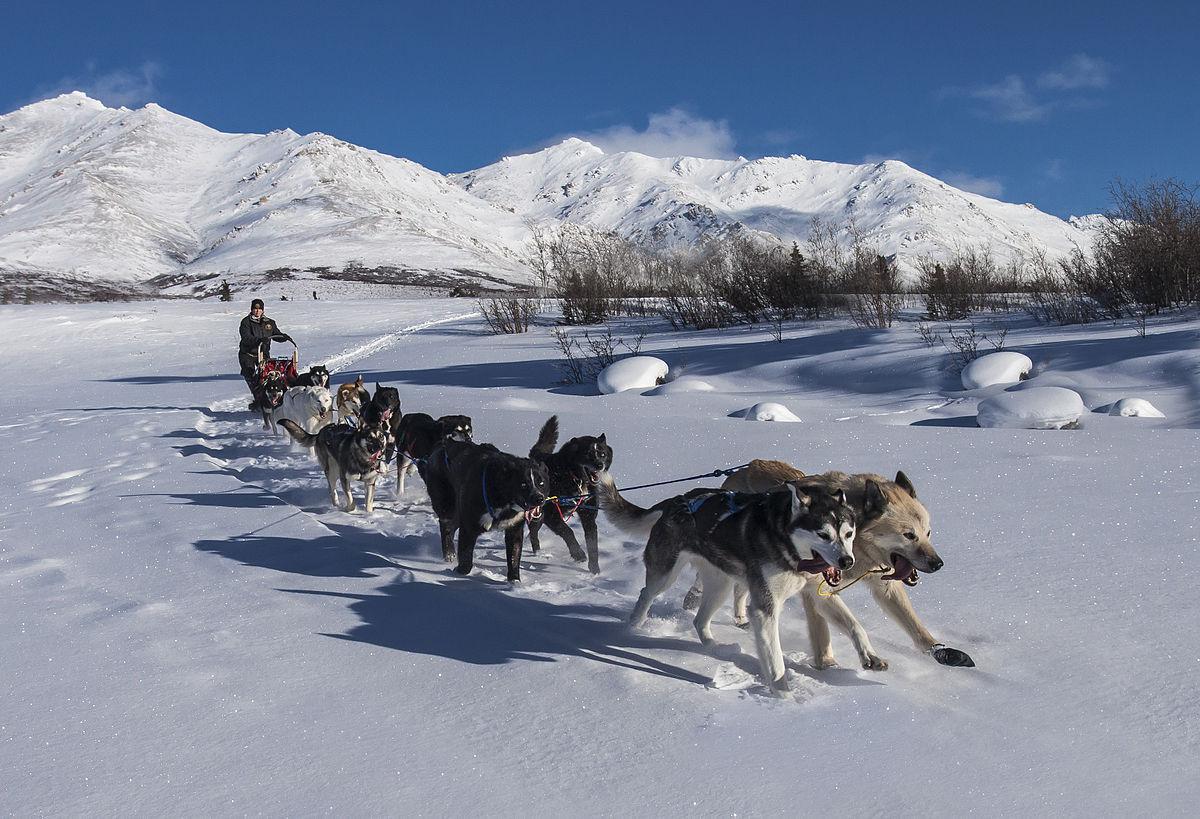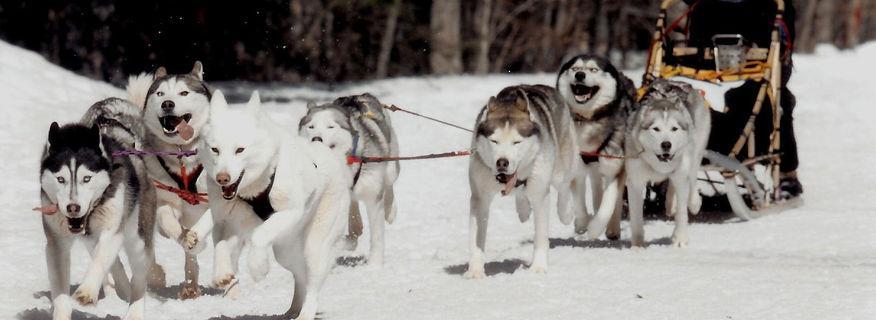The first image is the image on the left, the second image is the image on the right. Given the left and right images, does the statement "Both images show sled dog teams headed rightward and downward." hold true? Answer yes or no. No. The first image is the image on the left, the second image is the image on the right. For the images displayed, is the sentence "The dogs are heading toward the left in the image on the right." factually correct? Answer yes or no. Yes. 